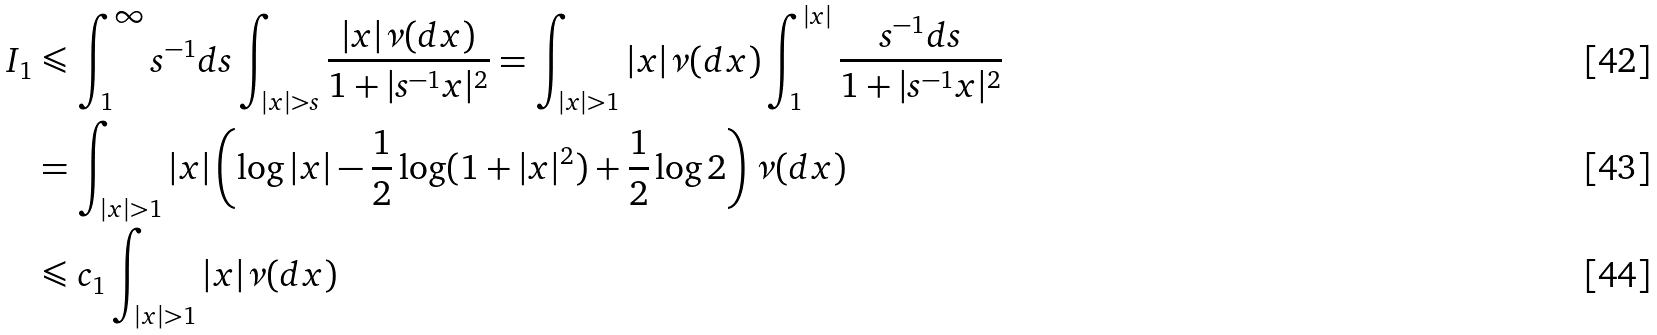Convert formula to latex. <formula><loc_0><loc_0><loc_500><loc_500>I _ { 1 } & \leqslant \int _ { 1 } ^ { \infty } s ^ { - 1 } d s \int _ { | x | > s } \frac { | x | \nu ( d x ) } { 1 + | s ^ { - 1 } x | ^ { 2 } } = \int _ { | x | > 1 } | x | \nu ( d x ) \int _ { 1 } ^ { | x | } \frac { s ^ { - 1 } d s } { 1 + | s ^ { - 1 } x | ^ { 2 } } \\ & = \int _ { | x | > 1 } | x | \left ( \log | x | - \frac { 1 } { 2 } \log ( 1 + | x | ^ { 2 } ) + \frac { 1 } { 2 } \log 2 \right ) \nu ( d x ) \\ & \leqslant c _ { 1 } \int _ { | x | > 1 } | x | \nu ( d x )</formula> 